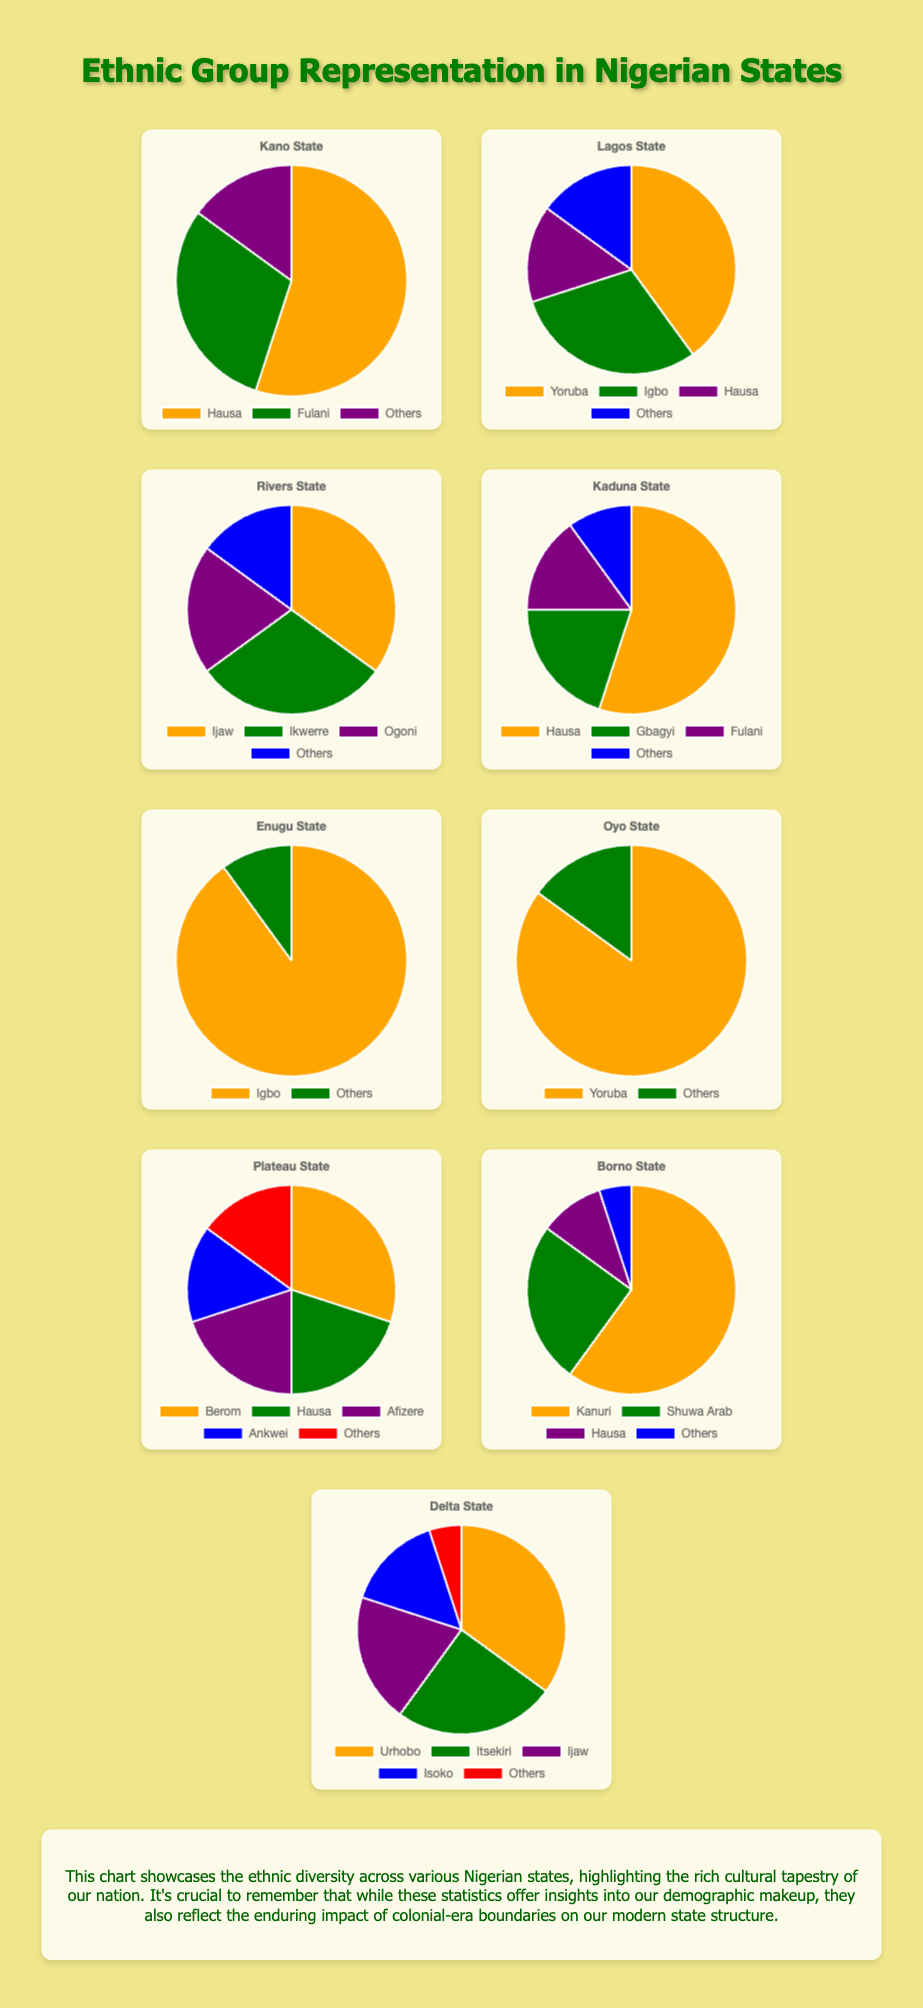What is the total percentage of the Hausa ethnic group across all states? First, identify the percentages for Hausa in each state: Kano (55%), Lagos (15%), Kaduna (55%), Plateau (20%), Borno (10%). Sum these percentages: 55 + 15 + 55 + 20 + 10 = 155.
Answer: 155% Which state has the highest representation of an ethnic group, and what is this group? Look at each state's chart to identify the highest percentage. Enugu State shows the highest representation with the Igbo ethnic group at 90%.
Answer: Enugu State, Igbo Compare the representation of Yoruba in Lagos State and Oyo State. Which state has a higher percentage of Yoruba? By how much? Yoruba in Lagos is 40%, and in Oyo is 85%. The difference is 85 - 40 = 45. Oyo State has a higher percentage by 45%.
Answer: Oyo State by 45% What's the percentage difference between Ijaw in Rivers State and Delta State? Ijaw in Rivers is 35%, and in Delta is 20%. The difference is 35 - 20 = 15.
Answer: 15% In which states do the 'Others' category make up 15% of the population? Identify the states where the 'Others' category is 15%. They are Kano, Lagos, Rivers, Plateau, and Oyo.
Answer: Kano, Lagos, Rivers, Plateau, Oyo What is the least represented ethnic group in Kaduna State, and what percentage do they represent? Look at Kaduna State's chart and check the percentages. 'Others' represent 10%, which is the least.
Answer: Others, 10% Calculate the average representation of the Fulani ethnic group in the states where they are present. Fulani is present in Kano (30%) and Kaduna (15%). The average representation is (30 + 15) / 2 = 22.5%.
Answer: 22.5% Compare the total percentage of Igbo and Hausa across all states. Which is higher, and by how much? First, sum the percentages for Igbo: Lagos (30%), Enugu (90%) = 120%. Hausa: Kano (55%), Lagos (15%), Kaduna (55%), Plateau (20%), Borno (10%) = 155%. The Hausa percentage is higher by 155 - 120 = 35.
Answer: Hausa by 35% Which states have more than two ethnic groups with representation over 20% each? Identify the states with more than two such groups: Lagos (Yoruba 40%, Igbo 30%, Hausa 15% - No), Rivers (Ijaw 35%, Ikwerre 30%, Ogoni 20% - Yes), Delta (Urhobo 35%, Itsekiri 25%, Ijaw 20%, Isoko 15% - Yes).
Answer: Rivers, Delta 